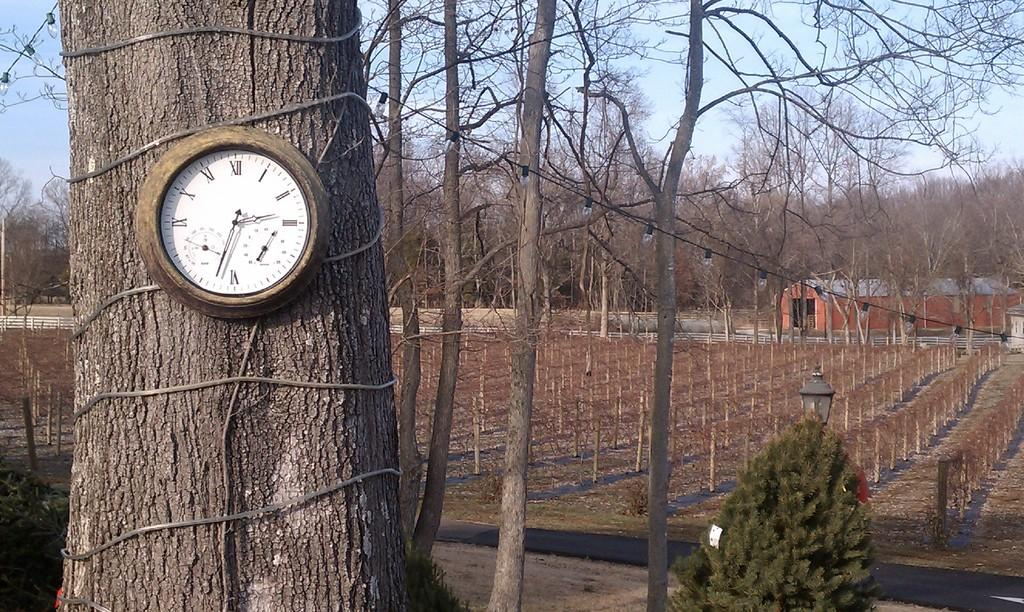<image>
Describe the image concisely. A round clock with a wooden frame and roman numerals tied to a tree outdoors near a wire fence. 